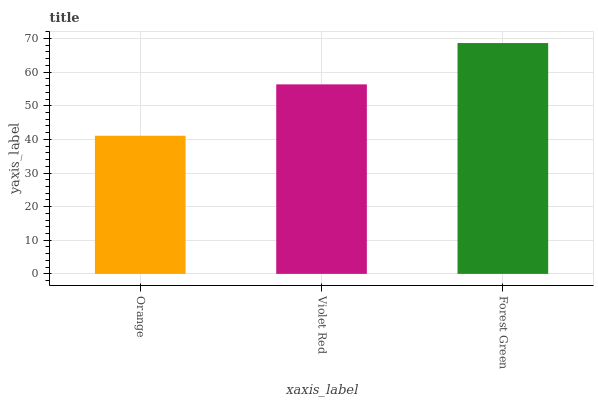Is Orange the minimum?
Answer yes or no. Yes. Is Forest Green the maximum?
Answer yes or no. Yes. Is Violet Red the minimum?
Answer yes or no. No. Is Violet Red the maximum?
Answer yes or no. No. Is Violet Red greater than Orange?
Answer yes or no. Yes. Is Orange less than Violet Red?
Answer yes or no. Yes. Is Orange greater than Violet Red?
Answer yes or no. No. Is Violet Red less than Orange?
Answer yes or no. No. Is Violet Red the high median?
Answer yes or no. Yes. Is Violet Red the low median?
Answer yes or no. Yes. Is Forest Green the high median?
Answer yes or no. No. Is Forest Green the low median?
Answer yes or no. No. 